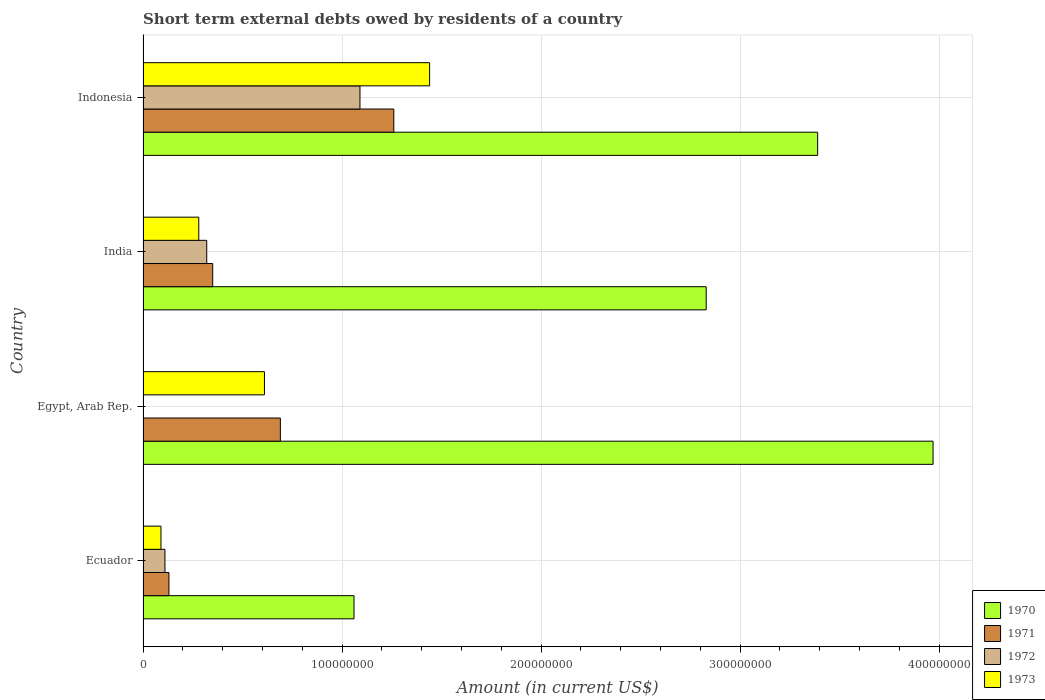How many different coloured bars are there?
Your answer should be compact. 4. Are the number of bars per tick equal to the number of legend labels?
Make the answer very short. No. Are the number of bars on each tick of the Y-axis equal?
Offer a very short reply. No. How many bars are there on the 1st tick from the bottom?
Offer a terse response. 4. What is the label of the 3rd group of bars from the top?
Provide a succinct answer. Egypt, Arab Rep. In how many cases, is the number of bars for a given country not equal to the number of legend labels?
Keep it short and to the point. 1. What is the amount of short-term external debts owed by residents in 1973 in Indonesia?
Your answer should be very brief. 1.44e+08. Across all countries, what is the maximum amount of short-term external debts owed by residents in 1970?
Offer a very short reply. 3.97e+08. Across all countries, what is the minimum amount of short-term external debts owed by residents in 1970?
Offer a very short reply. 1.06e+08. What is the total amount of short-term external debts owed by residents in 1970 in the graph?
Your response must be concise. 1.12e+09. What is the difference between the amount of short-term external debts owed by residents in 1971 in Ecuador and that in Indonesia?
Your answer should be compact. -1.13e+08. What is the difference between the amount of short-term external debts owed by residents in 1972 in India and the amount of short-term external debts owed by residents in 1973 in Ecuador?
Provide a short and direct response. 2.30e+07. What is the average amount of short-term external debts owed by residents in 1972 per country?
Provide a short and direct response. 3.80e+07. What is the difference between the amount of short-term external debts owed by residents in 1972 and amount of short-term external debts owed by residents in 1971 in Indonesia?
Keep it short and to the point. -1.70e+07. What is the ratio of the amount of short-term external debts owed by residents in 1970 in Ecuador to that in Indonesia?
Keep it short and to the point. 0.31. Is the amount of short-term external debts owed by residents in 1971 in India less than that in Indonesia?
Offer a terse response. Yes. What is the difference between the highest and the second highest amount of short-term external debts owed by residents in 1972?
Ensure brevity in your answer.  7.70e+07. What is the difference between the highest and the lowest amount of short-term external debts owed by residents in 1973?
Ensure brevity in your answer.  1.35e+08. In how many countries, is the amount of short-term external debts owed by residents in 1971 greater than the average amount of short-term external debts owed by residents in 1971 taken over all countries?
Keep it short and to the point. 2. Is the sum of the amount of short-term external debts owed by residents in 1973 in Egypt, Arab Rep. and India greater than the maximum amount of short-term external debts owed by residents in 1970 across all countries?
Provide a short and direct response. No. Is it the case that in every country, the sum of the amount of short-term external debts owed by residents in 1972 and amount of short-term external debts owed by residents in 1971 is greater than the sum of amount of short-term external debts owed by residents in 1973 and amount of short-term external debts owed by residents in 1970?
Your response must be concise. No. Is it the case that in every country, the sum of the amount of short-term external debts owed by residents in 1971 and amount of short-term external debts owed by residents in 1973 is greater than the amount of short-term external debts owed by residents in 1972?
Provide a succinct answer. Yes. How many bars are there?
Ensure brevity in your answer.  15. Are the values on the major ticks of X-axis written in scientific E-notation?
Provide a short and direct response. No. Does the graph contain any zero values?
Your response must be concise. Yes. Where does the legend appear in the graph?
Offer a terse response. Bottom right. How many legend labels are there?
Your answer should be compact. 4. How are the legend labels stacked?
Your answer should be very brief. Vertical. What is the title of the graph?
Ensure brevity in your answer.  Short term external debts owed by residents of a country. Does "1977" appear as one of the legend labels in the graph?
Make the answer very short. No. What is the label or title of the X-axis?
Provide a succinct answer. Amount (in current US$). What is the label or title of the Y-axis?
Keep it short and to the point. Country. What is the Amount (in current US$) of 1970 in Ecuador?
Make the answer very short. 1.06e+08. What is the Amount (in current US$) of 1971 in Ecuador?
Your answer should be very brief. 1.30e+07. What is the Amount (in current US$) in 1972 in Ecuador?
Offer a very short reply. 1.10e+07. What is the Amount (in current US$) in 1973 in Ecuador?
Keep it short and to the point. 9.00e+06. What is the Amount (in current US$) in 1970 in Egypt, Arab Rep.?
Offer a terse response. 3.97e+08. What is the Amount (in current US$) in 1971 in Egypt, Arab Rep.?
Offer a very short reply. 6.90e+07. What is the Amount (in current US$) in 1973 in Egypt, Arab Rep.?
Keep it short and to the point. 6.10e+07. What is the Amount (in current US$) of 1970 in India?
Your response must be concise. 2.83e+08. What is the Amount (in current US$) in 1971 in India?
Provide a short and direct response. 3.50e+07. What is the Amount (in current US$) in 1972 in India?
Make the answer very short. 3.20e+07. What is the Amount (in current US$) of 1973 in India?
Ensure brevity in your answer.  2.80e+07. What is the Amount (in current US$) in 1970 in Indonesia?
Give a very brief answer. 3.39e+08. What is the Amount (in current US$) in 1971 in Indonesia?
Offer a very short reply. 1.26e+08. What is the Amount (in current US$) in 1972 in Indonesia?
Your response must be concise. 1.09e+08. What is the Amount (in current US$) in 1973 in Indonesia?
Your response must be concise. 1.44e+08. Across all countries, what is the maximum Amount (in current US$) of 1970?
Provide a short and direct response. 3.97e+08. Across all countries, what is the maximum Amount (in current US$) in 1971?
Provide a succinct answer. 1.26e+08. Across all countries, what is the maximum Amount (in current US$) in 1972?
Provide a short and direct response. 1.09e+08. Across all countries, what is the maximum Amount (in current US$) in 1973?
Ensure brevity in your answer.  1.44e+08. Across all countries, what is the minimum Amount (in current US$) of 1970?
Provide a short and direct response. 1.06e+08. Across all countries, what is the minimum Amount (in current US$) of 1971?
Keep it short and to the point. 1.30e+07. Across all countries, what is the minimum Amount (in current US$) of 1972?
Your answer should be compact. 0. Across all countries, what is the minimum Amount (in current US$) of 1973?
Your answer should be very brief. 9.00e+06. What is the total Amount (in current US$) in 1970 in the graph?
Provide a short and direct response. 1.12e+09. What is the total Amount (in current US$) of 1971 in the graph?
Offer a terse response. 2.43e+08. What is the total Amount (in current US$) of 1972 in the graph?
Provide a succinct answer. 1.52e+08. What is the total Amount (in current US$) in 1973 in the graph?
Give a very brief answer. 2.42e+08. What is the difference between the Amount (in current US$) of 1970 in Ecuador and that in Egypt, Arab Rep.?
Offer a terse response. -2.91e+08. What is the difference between the Amount (in current US$) of 1971 in Ecuador and that in Egypt, Arab Rep.?
Offer a terse response. -5.60e+07. What is the difference between the Amount (in current US$) of 1973 in Ecuador and that in Egypt, Arab Rep.?
Your answer should be very brief. -5.20e+07. What is the difference between the Amount (in current US$) of 1970 in Ecuador and that in India?
Make the answer very short. -1.77e+08. What is the difference between the Amount (in current US$) in 1971 in Ecuador and that in India?
Offer a terse response. -2.20e+07. What is the difference between the Amount (in current US$) of 1972 in Ecuador and that in India?
Your response must be concise. -2.10e+07. What is the difference between the Amount (in current US$) in 1973 in Ecuador and that in India?
Your answer should be compact. -1.90e+07. What is the difference between the Amount (in current US$) in 1970 in Ecuador and that in Indonesia?
Provide a short and direct response. -2.33e+08. What is the difference between the Amount (in current US$) in 1971 in Ecuador and that in Indonesia?
Give a very brief answer. -1.13e+08. What is the difference between the Amount (in current US$) of 1972 in Ecuador and that in Indonesia?
Offer a very short reply. -9.80e+07. What is the difference between the Amount (in current US$) of 1973 in Ecuador and that in Indonesia?
Your answer should be compact. -1.35e+08. What is the difference between the Amount (in current US$) of 1970 in Egypt, Arab Rep. and that in India?
Offer a terse response. 1.14e+08. What is the difference between the Amount (in current US$) in 1971 in Egypt, Arab Rep. and that in India?
Ensure brevity in your answer.  3.40e+07. What is the difference between the Amount (in current US$) of 1973 in Egypt, Arab Rep. and that in India?
Provide a short and direct response. 3.30e+07. What is the difference between the Amount (in current US$) of 1970 in Egypt, Arab Rep. and that in Indonesia?
Ensure brevity in your answer.  5.80e+07. What is the difference between the Amount (in current US$) in 1971 in Egypt, Arab Rep. and that in Indonesia?
Ensure brevity in your answer.  -5.70e+07. What is the difference between the Amount (in current US$) of 1973 in Egypt, Arab Rep. and that in Indonesia?
Make the answer very short. -8.30e+07. What is the difference between the Amount (in current US$) in 1970 in India and that in Indonesia?
Keep it short and to the point. -5.60e+07. What is the difference between the Amount (in current US$) of 1971 in India and that in Indonesia?
Provide a short and direct response. -9.10e+07. What is the difference between the Amount (in current US$) in 1972 in India and that in Indonesia?
Your answer should be compact. -7.70e+07. What is the difference between the Amount (in current US$) in 1973 in India and that in Indonesia?
Your response must be concise. -1.16e+08. What is the difference between the Amount (in current US$) of 1970 in Ecuador and the Amount (in current US$) of 1971 in Egypt, Arab Rep.?
Your response must be concise. 3.70e+07. What is the difference between the Amount (in current US$) of 1970 in Ecuador and the Amount (in current US$) of 1973 in Egypt, Arab Rep.?
Give a very brief answer. 4.50e+07. What is the difference between the Amount (in current US$) in 1971 in Ecuador and the Amount (in current US$) in 1973 in Egypt, Arab Rep.?
Offer a very short reply. -4.80e+07. What is the difference between the Amount (in current US$) of 1972 in Ecuador and the Amount (in current US$) of 1973 in Egypt, Arab Rep.?
Make the answer very short. -5.00e+07. What is the difference between the Amount (in current US$) in 1970 in Ecuador and the Amount (in current US$) in 1971 in India?
Keep it short and to the point. 7.10e+07. What is the difference between the Amount (in current US$) of 1970 in Ecuador and the Amount (in current US$) of 1972 in India?
Your answer should be very brief. 7.40e+07. What is the difference between the Amount (in current US$) of 1970 in Ecuador and the Amount (in current US$) of 1973 in India?
Your answer should be very brief. 7.80e+07. What is the difference between the Amount (in current US$) in 1971 in Ecuador and the Amount (in current US$) in 1972 in India?
Offer a very short reply. -1.90e+07. What is the difference between the Amount (in current US$) in 1971 in Ecuador and the Amount (in current US$) in 1973 in India?
Provide a succinct answer. -1.50e+07. What is the difference between the Amount (in current US$) of 1972 in Ecuador and the Amount (in current US$) of 1973 in India?
Keep it short and to the point. -1.70e+07. What is the difference between the Amount (in current US$) in 1970 in Ecuador and the Amount (in current US$) in 1971 in Indonesia?
Give a very brief answer. -2.00e+07. What is the difference between the Amount (in current US$) in 1970 in Ecuador and the Amount (in current US$) in 1973 in Indonesia?
Give a very brief answer. -3.80e+07. What is the difference between the Amount (in current US$) in 1971 in Ecuador and the Amount (in current US$) in 1972 in Indonesia?
Give a very brief answer. -9.60e+07. What is the difference between the Amount (in current US$) in 1971 in Ecuador and the Amount (in current US$) in 1973 in Indonesia?
Provide a short and direct response. -1.31e+08. What is the difference between the Amount (in current US$) of 1972 in Ecuador and the Amount (in current US$) of 1973 in Indonesia?
Give a very brief answer. -1.33e+08. What is the difference between the Amount (in current US$) in 1970 in Egypt, Arab Rep. and the Amount (in current US$) in 1971 in India?
Your answer should be very brief. 3.62e+08. What is the difference between the Amount (in current US$) in 1970 in Egypt, Arab Rep. and the Amount (in current US$) in 1972 in India?
Give a very brief answer. 3.65e+08. What is the difference between the Amount (in current US$) of 1970 in Egypt, Arab Rep. and the Amount (in current US$) of 1973 in India?
Offer a terse response. 3.69e+08. What is the difference between the Amount (in current US$) in 1971 in Egypt, Arab Rep. and the Amount (in current US$) in 1972 in India?
Provide a short and direct response. 3.70e+07. What is the difference between the Amount (in current US$) in 1971 in Egypt, Arab Rep. and the Amount (in current US$) in 1973 in India?
Keep it short and to the point. 4.10e+07. What is the difference between the Amount (in current US$) of 1970 in Egypt, Arab Rep. and the Amount (in current US$) of 1971 in Indonesia?
Your response must be concise. 2.71e+08. What is the difference between the Amount (in current US$) of 1970 in Egypt, Arab Rep. and the Amount (in current US$) of 1972 in Indonesia?
Your answer should be compact. 2.88e+08. What is the difference between the Amount (in current US$) of 1970 in Egypt, Arab Rep. and the Amount (in current US$) of 1973 in Indonesia?
Make the answer very short. 2.53e+08. What is the difference between the Amount (in current US$) in 1971 in Egypt, Arab Rep. and the Amount (in current US$) in 1972 in Indonesia?
Offer a very short reply. -4.00e+07. What is the difference between the Amount (in current US$) of 1971 in Egypt, Arab Rep. and the Amount (in current US$) of 1973 in Indonesia?
Your answer should be compact. -7.50e+07. What is the difference between the Amount (in current US$) in 1970 in India and the Amount (in current US$) in 1971 in Indonesia?
Keep it short and to the point. 1.57e+08. What is the difference between the Amount (in current US$) in 1970 in India and the Amount (in current US$) in 1972 in Indonesia?
Provide a short and direct response. 1.74e+08. What is the difference between the Amount (in current US$) in 1970 in India and the Amount (in current US$) in 1973 in Indonesia?
Make the answer very short. 1.39e+08. What is the difference between the Amount (in current US$) in 1971 in India and the Amount (in current US$) in 1972 in Indonesia?
Offer a very short reply. -7.40e+07. What is the difference between the Amount (in current US$) in 1971 in India and the Amount (in current US$) in 1973 in Indonesia?
Make the answer very short. -1.09e+08. What is the difference between the Amount (in current US$) in 1972 in India and the Amount (in current US$) in 1973 in Indonesia?
Provide a succinct answer. -1.12e+08. What is the average Amount (in current US$) in 1970 per country?
Keep it short and to the point. 2.81e+08. What is the average Amount (in current US$) in 1971 per country?
Offer a very short reply. 6.08e+07. What is the average Amount (in current US$) of 1972 per country?
Offer a very short reply. 3.80e+07. What is the average Amount (in current US$) in 1973 per country?
Your answer should be very brief. 6.05e+07. What is the difference between the Amount (in current US$) of 1970 and Amount (in current US$) of 1971 in Ecuador?
Keep it short and to the point. 9.30e+07. What is the difference between the Amount (in current US$) of 1970 and Amount (in current US$) of 1972 in Ecuador?
Offer a very short reply. 9.50e+07. What is the difference between the Amount (in current US$) in 1970 and Amount (in current US$) in 1973 in Ecuador?
Your response must be concise. 9.70e+07. What is the difference between the Amount (in current US$) of 1971 and Amount (in current US$) of 1972 in Ecuador?
Provide a succinct answer. 2.00e+06. What is the difference between the Amount (in current US$) of 1972 and Amount (in current US$) of 1973 in Ecuador?
Make the answer very short. 2.00e+06. What is the difference between the Amount (in current US$) in 1970 and Amount (in current US$) in 1971 in Egypt, Arab Rep.?
Provide a short and direct response. 3.28e+08. What is the difference between the Amount (in current US$) of 1970 and Amount (in current US$) of 1973 in Egypt, Arab Rep.?
Your response must be concise. 3.36e+08. What is the difference between the Amount (in current US$) of 1970 and Amount (in current US$) of 1971 in India?
Your response must be concise. 2.48e+08. What is the difference between the Amount (in current US$) in 1970 and Amount (in current US$) in 1972 in India?
Your answer should be compact. 2.51e+08. What is the difference between the Amount (in current US$) in 1970 and Amount (in current US$) in 1973 in India?
Your answer should be compact. 2.55e+08. What is the difference between the Amount (in current US$) in 1971 and Amount (in current US$) in 1972 in India?
Ensure brevity in your answer.  3.00e+06. What is the difference between the Amount (in current US$) of 1971 and Amount (in current US$) of 1973 in India?
Provide a short and direct response. 7.00e+06. What is the difference between the Amount (in current US$) of 1972 and Amount (in current US$) of 1973 in India?
Make the answer very short. 4.00e+06. What is the difference between the Amount (in current US$) of 1970 and Amount (in current US$) of 1971 in Indonesia?
Keep it short and to the point. 2.13e+08. What is the difference between the Amount (in current US$) of 1970 and Amount (in current US$) of 1972 in Indonesia?
Provide a short and direct response. 2.30e+08. What is the difference between the Amount (in current US$) in 1970 and Amount (in current US$) in 1973 in Indonesia?
Your answer should be compact. 1.95e+08. What is the difference between the Amount (in current US$) of 1971 and Amount (in current US$) of 1972 in Indonesia?
Your answer should be very brief. 1.70e+07. What is the difference between the Amount (in current US$) in 1971 and Amount (in current US$) in 1973 in Indonesia?
Keep it short and to the point. -1.80e+07. What is the difference between the Amount (in current US$) in 1972 and Amount (in current US$) in 1973 in Indonesia?
Make the answer very short. -3.50e+07. What is the ratio of the Amount (in current US$) in 1970 in Ecuador to that in Egypt, Arab Rep.?
Ensure brevity in your answer.  0.27. What is the ratio of the Amount (in current US$) in 1971 in Ecuador to that in Egypt, Arab Rep.?
Provide a short and direct response. 0.19. What is the ratio of the Amount (in current US$) in 1973 in Ecuador to that in Egypt, Arab Rep.?
Ensure brevity in your answer.  0.15. What is the ratio of the Amount (in current US$) in 1970 in Ecuador to that in India?
Your answer should be compact. 0.37. What is the ratio of the Amount (in current US$) of 1971 in Ecuador to that in India?
Give a very brief answer. 0.37. What is the ratio of the Amount (in current US$) in 1972 in Ecuador to that in India?
Your response must be concise. 0.34. What is the ratio of the Amount (in current US$) of 1973 in Ecuador to that in India?
Keep it short and to the point. 0.32. What is the ratio of the Amount (in current US$) of 1970 in Ecuador to that in Indonesia?
Provide a short and direct response. 0.31. What is the ratio of the Amount (in current US$) in 1971 in Ecuador to that in Indonesia?
Your answer should be very brief. 0.1. What is the ratio of the Amount (in current US$) of 1972 in Ecuador to that in Indonesia?
Give a very brief answer. 0.1. What is the ratio of the Amount (in current US$) of 1973 in Ecuador to that in Indonesia?
Your answer should be compact. 0.06. What is the ratio of the Amount (in current US$) in 1970 in Egypt, Arab Rep. to that in India?
Give a very brief answer. 1.4. What is the ratio of the Amount (in current US$) of 1971 in Egypt, Arab Rep. to that in India?
Provide a succinct answer. 1.97. What is the ratio of the Amount (in current US$) in 1973 in Egypt, Arab Rep. to that in India?
Provide a short and direct response. 2.18. What is the ratio of the Amount (in current US$) in 1970 in Egypt, Arab Rep. to that in Indonesia?
Provide a succinct answer. 1.17. What is the ratio of the Amount (in current US$) of 1971 in Egypt, Arab Rep. to that in Indonesia?
Provide a short and direct response. 0.55. What is the ratio of the Amount (in current US$) in 1973 in Egypt, Arab Rep. to that in Indonesia?
Make the answer very short. 0.42. What is the ratio of the Amount (in current US$) in 1970 in India to that in Indonesia?
Keep it short and to the point. 0.83. What is the ratio of the Amount (in current US$) of 1971 in India to that in Indonesia?
Your answer should be compact. 0.28. What is the ratio of the Amount (in current US$) of 1972 in India to that in Indonesia?
Ensure brevity in your answer.  0.29. What is the ratio of the Amount (in current US$) in 1973 in India to that in Indonesia?
Your response must be concise. 0.19. What is the difference between the highest and the second highest Amount (in current US$) in 1970?
Provide a short and direct response. 5.80e+07. What is the difference between the highest and the second highest Amount (in current US$) in 1971?
Offer a very short reply. 5.70e+07. What is the difference between the highest and the second highest Amount (in current US$) of 1972?
Offer a very short reply. 7.70e+07. What is the difference between the highest and the second highest Amount (in current US$) of 1973?
Your answer should be compact. 8.30e+07. What is the difference between the highest and the lowest Amount (in current US$) in 1970?
Ensure brevity in your answer.  2.91e+08. What is the difference between the highest and the lowest Amount (in current US$) of 1971?
Keep it short and to the point. 1.13e+08. What is the difference between the highest and the lowest Amount (in current US$) of 1972?
Keep it short and to the point. 1.09e+08. What is the difference between the highest and the lowest Amount (in current US$) of 1973?
Ensure brevity in your answer.  1.35e+08. 